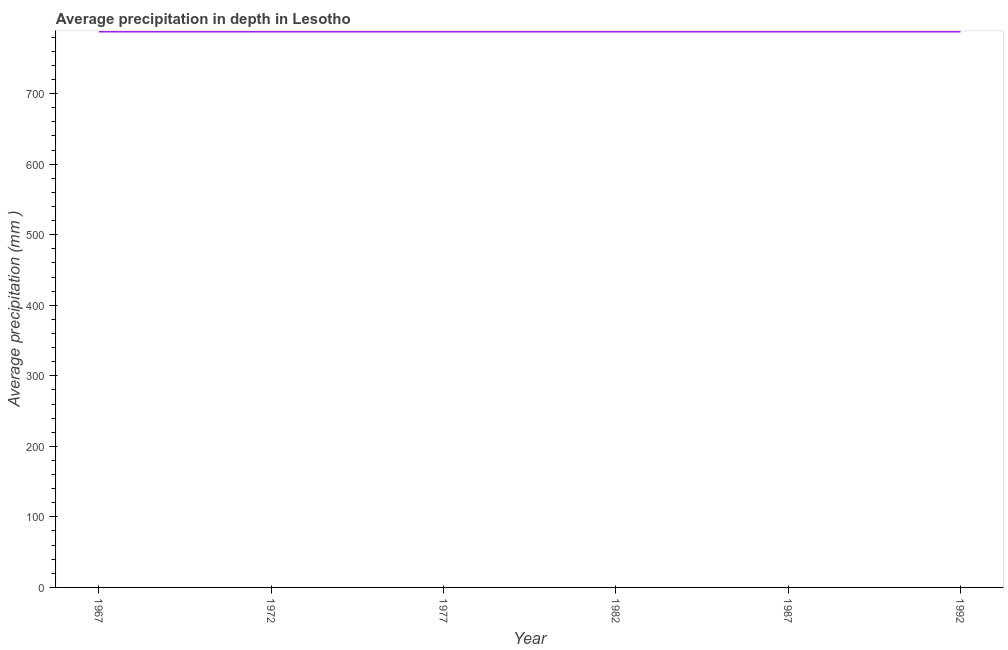What is the average precipitation in depth in 1967?
Give a very brief answer. 788. Across all years, what is the maximum average precipitation in depth?
Give a very brief answer. 788. Across all years, what is the minimum average precipitation in depth?
Keep it short and to the point. 788. In which year was the average precipitation in depth maximum?
Give a very brief answer. 1967. In which year was the average precipitation in depth minimum?
Your answer should be very brief. 1967. What is the sum of the average precipitation in depth?
Your answer should be compact. 4728. What is the difference between the average precipitation in depth in 1967 and 1977?
Offer a very short reply. 0. What is the average average precipitation in depth per year?
Keep it short and to the point. 788. What is the median average precipitation in depth?
Your answer should be compact. 788. In how many years, is the average precipitation in depth greater than 300 mm?
Provide a succinct answer. 6. Do a majority of the years between 1977 and 1972 (inclusive) have average precipitation in depth greater than 700 mm?
Your answer should be compact. No. Is the average precipitation in depth in 1972 less than that in 1992?
Offer a terse response. No. Is the difference between the average precipitation in depth in 1967 and 1982 greater than the difference between any two years?
Offer a very short reply. Yes. What is the difference between the highest and the second highest average precipitation in depth?
Offer a terse response. 0. Is the sum of the average precipitation in depth in 1977 and 1982 greater than the maximum average precipitation in depth across all years?
Provide a short and direct response. Yes. What is the difference between the highest and the lowest average precipitation in depth?
Make the answer very short. 0. In how many years, is the average precipitation in depth greater than the average average precipitation in depth taken over all years?
Your answer should be very brief. 0. How many lines are there?
Make the answer very short. 1. How many years are there in the graph?
Your answer should be very brief. 6. Are the values on the major ticks of Y-axis written in scientific E-notation?
Provide a succinct answer. No. What is the title of the graph?
Keep it short and to the point. Average precipitation in depth in Lesotho. What is the label or title of the Y-axis?
Offer a very short reply. Average precipitation (mm ). What is the Average precipitation (mm ) in 1967?
Provide a short and direct response. 788. What is the Average precipitation (mm ) of 1972?
Your answer should be compact. 788. What is the Average precipitation (mm ) in 1977?
Keep it short and to the point. 788. What is the Average precipitation (mm ) in 1982?
Give a very brief answer. 788. What is the Average precipitation (mm ) in 1987?
Your response must be concise. 788. What is the Average precipitation (mm ) of 1992?
Offer a terse response. 788. What is the difference between the Average precipitation (mm ) in 1967 and 1982?
Your response must be concise. 0. What is the difference between the Average precipitation (mm ) in 1967 and 1987?
Your answer should be very brief. 0. What is the difference between the Average precipitation (mm ) in 1972 and 1977?
Offer a very short reply. 0. What is the difference between the Average precipitation (mm ) in 1972 and 1982?
Give a very brief answer. 0. What is the difference between the Average precipitation (mm ) in 1972 and 1992?
Keep it short and to the point. 0. What is the difference between the Average precipitation (mm ) in 1977 and 1992?
Your response must be concise. 0. What is the ratio of the Average precipitation (mm ) in 1967 to that in 1972?
Your response must be concise. 1. What is the ratio of the Average precipitation (mm ) in 1967 to that in 1977?
Provide a succinct answer. 1. What is the ratio of the Average precipitation (mm ) in 1967 to that in 1987?
Offer a very short reply. 1. What is the ratio of the Average precipitation (mm ) in 1972 to that in 1977?
Provide a short and direct response. 1. What is the ratio of the Average precipitation (mm ) in 1977 to that in 1992?
Your answer should be very brief. 1. What is the ratio of the Average precipitation (mm ) in 1982 to that in 1987?
Offer a terse response. 1. What is the ratio of the Average precipitation (mm ) in 1982 to that in 1992?
Offer a very short reply. 1. 